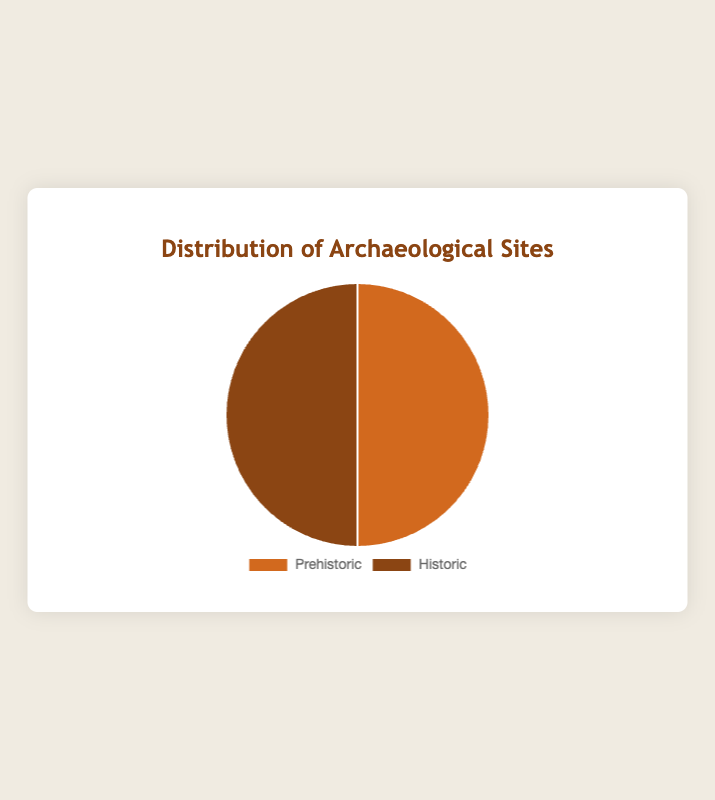What is the total number of Prehistoric and Historic archaeological sites documented? The pie chart shows two types of archaeological sites. By visually summing the counts for Prehistoric and Historic sites, you get 3 Prehistoric sites and 3 Historic sites, resulting in a total of 3 + 3 = 6.
Answer: 6 Which type of archaeological site has a larger count? The pie chart visually compares the counts of Prehistoric and Historic sites. Both sections occupy equal areas, indicating they have the same count.
Answer: They are equal What percentage of the documented sites are Prehistoric? The pie chart shows that the counts of Prehistoric and Historic sites are equal, each type occupying half of the chart. Therefore, the percentage of Prehistoric sites is 50%.
Answer: 50% What is the difference in the number of Prehistoric and Historic sites documented? The pie chart shows equal areas for Prehistoric and Historic sites, indicating there is no difference in the count. The difference is 0.
Answer: 0 What proportion of the pie chart is occupied by Historic sites? The pie chart is divided into two equal sections for Prehistoric and Historic sites. Thus, the proportion of Historic sites is 1/2 or 50%.
Answer: 50% If another Prehistoric site were documented, what would be the new percentage for Prehistoric sites? Adding one more Prehistoric site would bring the total number of sites to 7 (4 Prehistoric + 3 Historic). The new percentage for Prehistoric sites would be (4/7) * 100 ≈ 57.1%.
Answer: 57.1% Given the current number of sites, if one Historic site was found to be Prehistoric, how would this affect the percentages in the chart? Changing one Historic site to a Prehistoric site, there will be 4 Prehistoric and 2 Historic sites. The percentage for Prehistoric would be (4/6) * 100 ≈ 66.7%, and for Historic, it would be (2/6) * 100 ≈ 33.3%.
Answer: Prehistoric: 66.7%, Historic: 33.3% If a new archaeological site that doesn't belong to either category were discovered, how would the total number of sites change? Introducing a new type of archaeological site increases the total number of sites from 6 to 7. This change would affect the pie chart by adding another category, altering the distribution.
Answer: 7 How many times larger is the number of Prehistoric sites compared to Historic sites? The pie chart shows equal sections for both Prehistoric and Historic sites, thus the number of Prehistoric sites is 1 times the number of Historic sites.
Answer: 1 What would the pie chart look like if there were only one more Prehistoric site than Historic? If there were one more Prehistoric site (making 4 Prehistoric and 3 Historic), the Prehistoric section would occupy a larger portion of the pie chart, with a new percentage of (4/7) about 57.1% and Historic (3/7) about 42.9%.
Answer: Prehistoric: 57.1%, Historic: 42.9% 